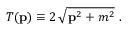Convert formula to latex. <formula><loc_0><loc_0><loc_500><loc_500>T ( { p } ) \equiv 2 \, \sqrt { { p } ^ { 2 } + m ^ { 2 } } \ .</formula> 